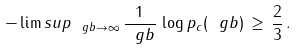<formula> <loc_0><loc_0><loc_500><loc_500>- \lim s u p _ { \ g b \to \infty } \, \frac { 1 } { \ g b } \, \log p _ { c } ( \ g b ) \, \geq \, \frac { 2 } { 3 } \, .</formula> 